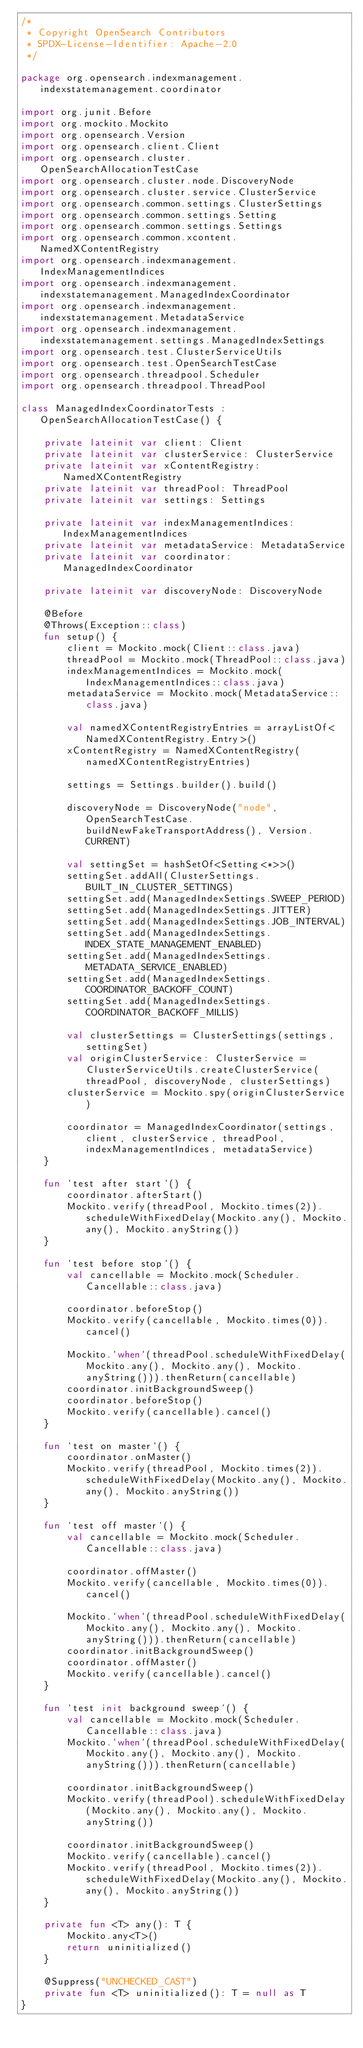Convert code to text. <code><loc_0><loc_0><loc_500><loc_500><_Kotlin_>/*
 * Copyright OpenSearch Contributors
 * SPDX-License-Identifier: Apache-2.0
 */

package org.opensearch.indexmanagement.indexstatemanagement.coordinator

import org.junit.Before
import org.mockito.Mockito
import org.opensearch.Version
import org.opensearch.client.Client
import org.opensearch.cluster.OpenSearchAllocationTestCase
import org.opensearch.cluster.node.DiscoveryNode
import org.opensearch.cluster.service.ClusterService
import org.opensearch.common.settings.ClusterSettings
import org.opensearch.common.settings.Setting
import org.opensearch.common.settings.Settings
import org.opensearch.common.xcontent.NamedXContentRegistry
import org.opensearch.indexmanagement.IndexManagementIndices
import org.opensearch.indexmanagement.indexstatemanagement.ManagedIndexCoordinator
import org.opensearch.indexmanagement.indexstatemanagement.MetadataService
import org.opensearch.indexmanagement.indexstatemanagement.settings.ManagedIndexSettings
import org.opensearch.test.ClusterServiceUtils
import org.opensearch.test.OpenSearchTestCase
import org.opensearch.threadpool.Scheduler
import org.opensearch.threadpool.ThreadPool

class ManagedIndexCoordinatorTests : OpenSearchAllocationTestCase() {

    private lateinit var client: Client
    private lateinit var clusterService: ClusterService
    private lateinit var xContentRegistry: NamedXContentRegistry
    private lateinit var threadPool: ThreadPool
    private lateinit var settings: Settings

    private lateinit var indexManagementIndices: IndexManagementIndices
    private lateinit var metadataService: MetadataService
    private lateinit var coordinator: ManagedIndexCoordinator

    private lateinit var discoveryNode: DiscoveryNode

    @Before
    @Throws(Exception::class)
    fun setup() {
        client = Mockito.mock(Client::class.java)
        threadPool = Mockito.mock(ThreadPool::class.java)
        indexManagementIndices = Mockito.mock(IndexManagementIndices::class.java)
        metadataService = Mockito.mock(MetadataService::class.java)

        val namedXContentRegistryEntries = arrayListOf<NamedXContentRegistry.Entry>()
        xContentRegistry = NamedXContentRegistry(namedXContentRegistryEntries)

        settings = Settings.builder().build()

        discoveryNode = DiscoveryNode("node", OpenSearchTestCase.buildNewFakeTransportAddress(), Version.CURRENT)

        val settingSet = hashSetOf<Setting<*>>()
        settingSet.addAll(ClusterSettings.BUILT_IN_CLUSTER_SETTINGS)
        settingSet.add(ManagedIndexSettings.SWEEP_PERIOD)
        settingSet.add(ManagedIndexSettings.JITTER)
        settingSet.add(ManagedIndexSettings.JOB_INTERVAL)
        settingSet.add(ManagedIndexSettings.INDEX_STATE_MANAGEMENT_ENABLED)
        settingSet.add(ManagedIndexSettings.METADATA_SERVICE_ENABLED)
        settingSet.add(ManagedIndexSettings.COORDINATOR_BACKOFF_COUNT)
        settingSet.add(ManagedIndexSettings.COORDINATOR_BACKOFF_MILLIS)

        val clusterSettings = ClusterSettings(settings, settingSet)
        val originClusterService: ClusterService = ClusterServiceUtils.createClusterService(threadPool, discoveryNode, clusterSettings)
        clusterService = Mockito.spy(originClusterService)

        coordinator = ManagedIndexCoordinator(settings, client, clusterService, threadPool, indexManagementIndices, metadataService)
    }

    fun `test after start`() {
        coordinator.afterStart()
        Mockito.verify(threadPool, Mockito.times(2)).scheduleWithFixedDelay(Mockito.any(), Mockito.any(), Mockito.anyString())
    }

    fun `test before stop`() {
        val cancellable = Mockito.mock(Scheduler.Cancellable::class.java)

        coordinator.beforeStop()
        Mockito.verify(cancellable, Mockito.times(0)).cancel()

        Mockito.`when`(threadPool.scheduleWithFixedDelay(Mockito.any(), Mockito.any(), Mockito.anyString())).thenReturn(cancellable)
        coordinator.initBackgroundSweep()
        coordinator.beforeStop()
        Mockito.verify(cancellable).cancel()
    }

    fun `test on master`() {
        coordinator.onMaster()
        Mockito.verify(threadPool, Mockito.times(2)).scheduleWithFixedDelay(Mockito.any(), Mockito.any(), Mockito.anyString())
    }

    fun `test off master`() {
        val cancellable = Mockito.mock(Scheduler.Cancellable::class.java)

        coordinator.offMaster()
        Mockito.verify(cancellable, Mockito.times(0)).cancel()

        Mockito.`when`(threadPool.scheduleWithFixedDelay(Mockito.any(), Mockito.any(), Mockito.anyString())).thenReturn(cancellable)
        coordinator.initBackgroundSweep()
        coordinator.offMaster()
        Mockito.verify(cancellable).cancel()
    }

    fun `test init background sweep`() {
        val cancellable = Mockito.mock(Scheduler.Cancellable::class.java)
        Mockito.`when`(threadPool.scheduleWithFixedDelay(Mockito.any(), Mockito.any(), Mockito.anyString())).thenReturn(cancellable)

        coordinator.initBackgroundSweep()
        Mockito.verify(threadPool).scheduleWithFixedDelay(Mockito.any(), Mockito.any(), Mockito.anyString())

        coordinator.initBackgroundSweep()
        Mockito.verify(cancellable).cancel()
        Mockito.verify(threadPool, Mockito.times(2)).scheduleWithFixedDelay(Mockito.any(), Mockito.any(), Mockito.anyString())
    }

    private fun <T> any(): T {
        Mockito.any<T>()
        return uninitialized()
    }

    @Suppress("UNCHECKED_CAST")
    private fun <T> uninitialized(): T = null as T
}
</code> 